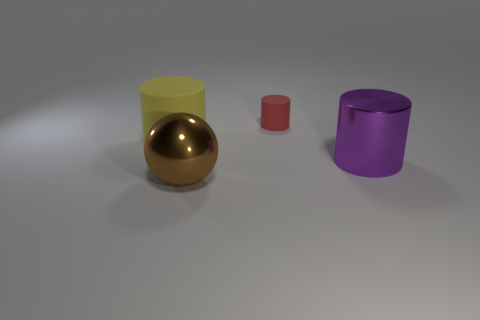Add 1 small purple matte blocks. How many objects exist? 5 Subtract all cylinders. How many objects are left? 1 Add 3 large metallic objects. How many large metallic objects are left? 5 Add 1 green rubber cylinders. How many green rubber cylinders exist? 1 Subtract 0 red spheres. How many objects are left? 4 Subtract all small brown spheres. Subtract all red things. How many objects are left? 3 